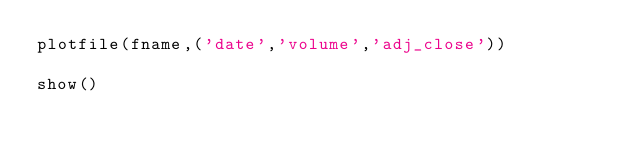Convert code to text. <code><loc_0><loc_0><loc_500><loc_500><_Python_>plotfile(fname,('date','volume','adj_close'))

show()
</code> 